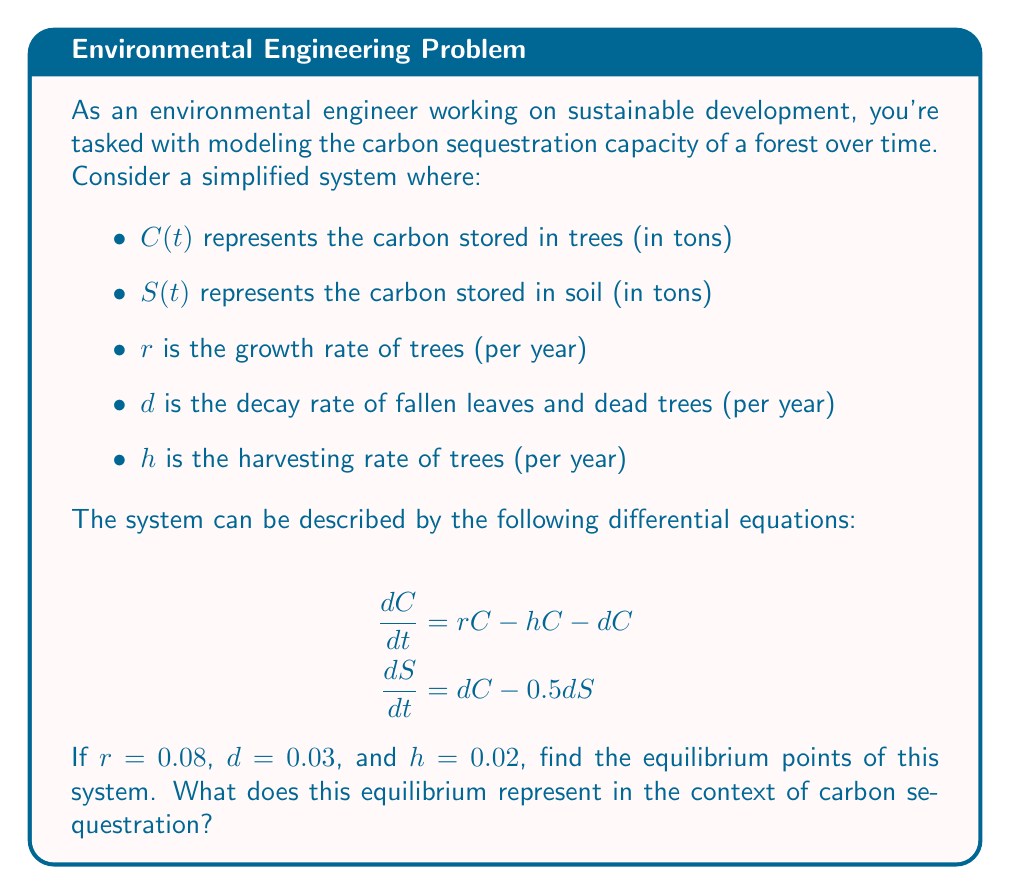Show me your answer to this math problem. To find the equilibrium points, we set both derivatives to zero:

1) Set $\frac{dC}{dt} = 0$ and $\frac{dS}{dt} = 0$:

   $$\begin{align}
   0 &= rC - hC - dC \\
   0 &= dC - 0.5dS
   \end{align}$$

2) From the first equation:
   
   $$\begin{align}
   0 &= rC - hC - dC \\
   0 &= (r - h - d)C \\
   0 &= (0.08 - 0.02 - 0.03)C \\
   0 &= 0.03C
   \end{align}$$

3) This is satisfied when $C = 0$. However, we also need to consider the case where the coefficient is zero, which it is in this case (0.03).

4) From the second equation:
   
   $$\begin{align}
   0 &= dC - 0.5dS \\
   0.5dS &= dC \\
   S &= 2C
   \end{align}$$

5) Since the coefficient in step 3 is zero, we have infinitely many equilibrium points. Any point $(C, 2C)$ is an equilibrium point.

6) In the context of carbon sequestration, this equilibrium represents a steady state where the rate of carbon absorption by trees equals the rate of carbon loss due to harvesting and decay. The soil carbon is maintained at twice the level of tree carbon.
Answer: Equilibrium points: $(C, 2C)$ for any $C \geq 0$ 